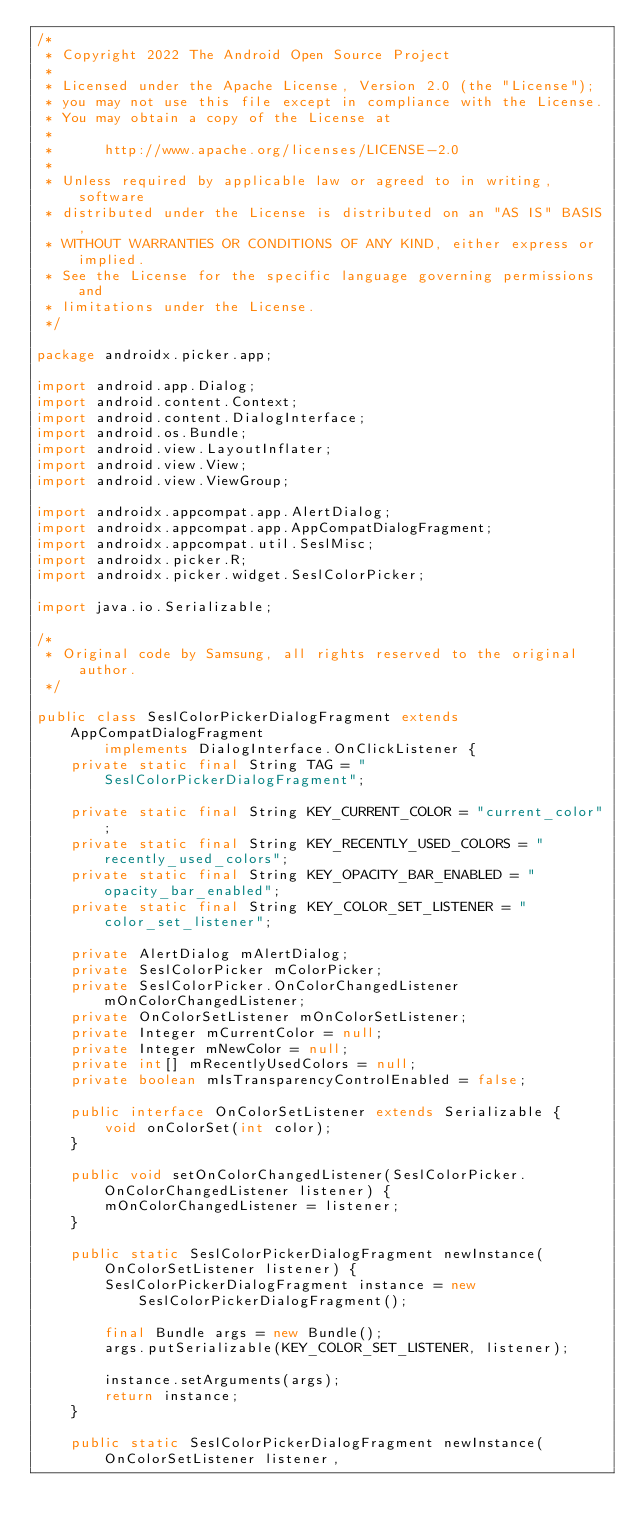Convert code to text. <code><loc_0><loc_0><loc_500><loc_500><_Java_>/*
 * Copyright 2022 The Android Open Source Project
 *
 * Licensed under the Apache License, Version 2.0 (the "License");
 * you may not use this file except in compliance with the License.
 * You may obtain a copy of the License at
 *
 *      http://www.apache.org/licenses/LICENSE-2.0
 *
 * Unless required by applicable law or agreed to in writing, software
 * distributed under the License is distributed on an "AS IS" BASIS,
 * WITHOUT WARRANTIES OR CONDITIONS OF ANY KIND, either express or implied.
 * See the License for the specific language governing permissions and
 * limitations under the License.
 */

package androidx.picker.app;

import android.app.Dialog;
import android.content.Context;
import android.content.DialogInterface;
import android.os.Bundle;
import android.view.LayoutInflater;
import android.view.View;
import android.view.ViewGroup;

import androidx.appcompat.app.AlertDialog;
import androidx.appcompat.app.AppCompatDialogFragment;
import androidx.appcompat.util.SeslMisc;
import androidx.picker.R;
import androidx.picker.widget.SeslColorPicker;

import java.io.Serializable;

/*
 * Original code by Samsung, all rights reserved to the original author.
 */

public class SeslColorPickerDialogFragment extends AppCompatDialogFragment
        implements DialogInterface.OnClickListener {
    private static final String TAG = "SeslColorPickerDialogFragment";

    private static final String KEY_CURRENT_COLOR = "current_color";
    private static final String KEY_RECENTLY_USED_COLORS = "recently_used_colors";
    private static final String KEY_OPACITY_BAR_ENABLED = "opacity_bar_enabled";
    private static final String KEY_COLOR_SET_LISTENER = "color_set_listener";

    private AlertDialog mAlertDialog;
    private SeslColorPicker mColorPicker;
    private SeslColorPicker.OnColorChangedListener mOnColorChangedListener;
    private OnColorSetListener mOnColorSetListener;
    private Integer mCurrentColor = null;
    private Integer mNewColor = null;
    private int[] mRecentlyUsedColors = null;
    private boolean mIsTransparencyControlEnabled = false;

    public interface OnColorSetListener extends Serializable {
        void onColorSet(int color);
    }

    public void setOnColorChangedListener(SeslColorPicker.OnColorChangedListener listener) {
        mOnColorChangedListener = listener;
    }

    public static SeslColorPickerDialogFragment newInstance(OnColorSetListener listener) {
        SeslColorPickerDialogFragment instance = new SeslColorPickerDialogFragment();

        final Bundle args = new Bundle();
        args.putSerializable(KEY_COLOR_SET_LISTENER, listener);

        instance.setArguments(args);
        return instance;
    }

    public static SeslColorPickerDialogFragment newInstance(OnColorSetListener listener,</code> 